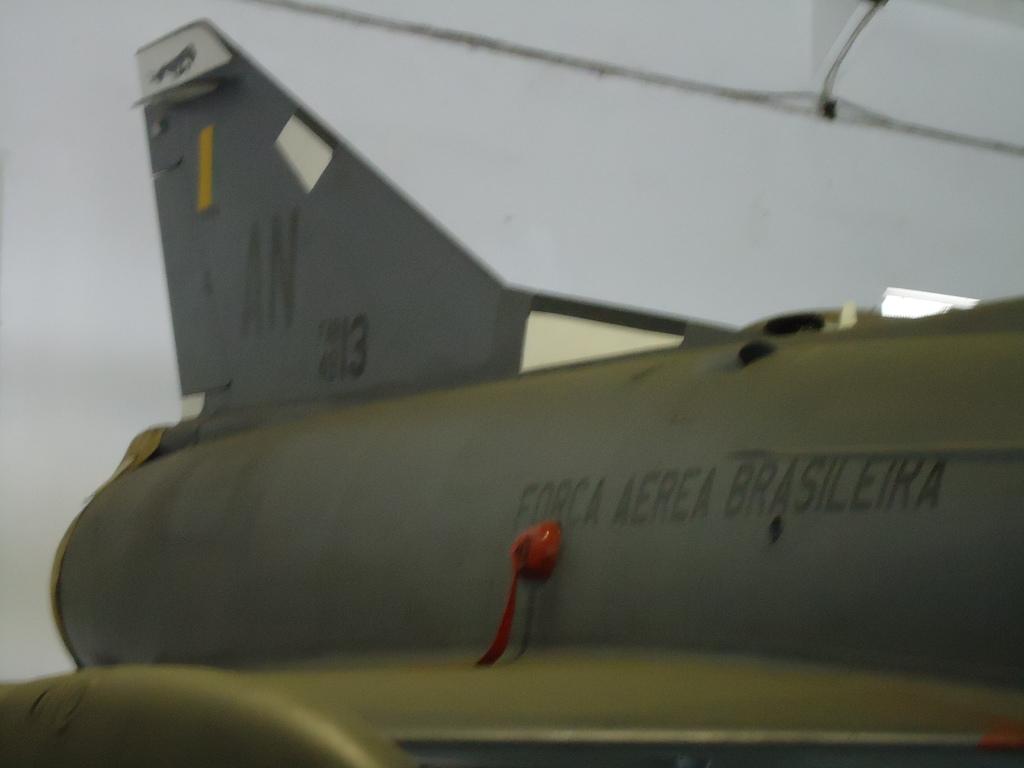What number is on the wing?
Provide a short and direct response. 13. 